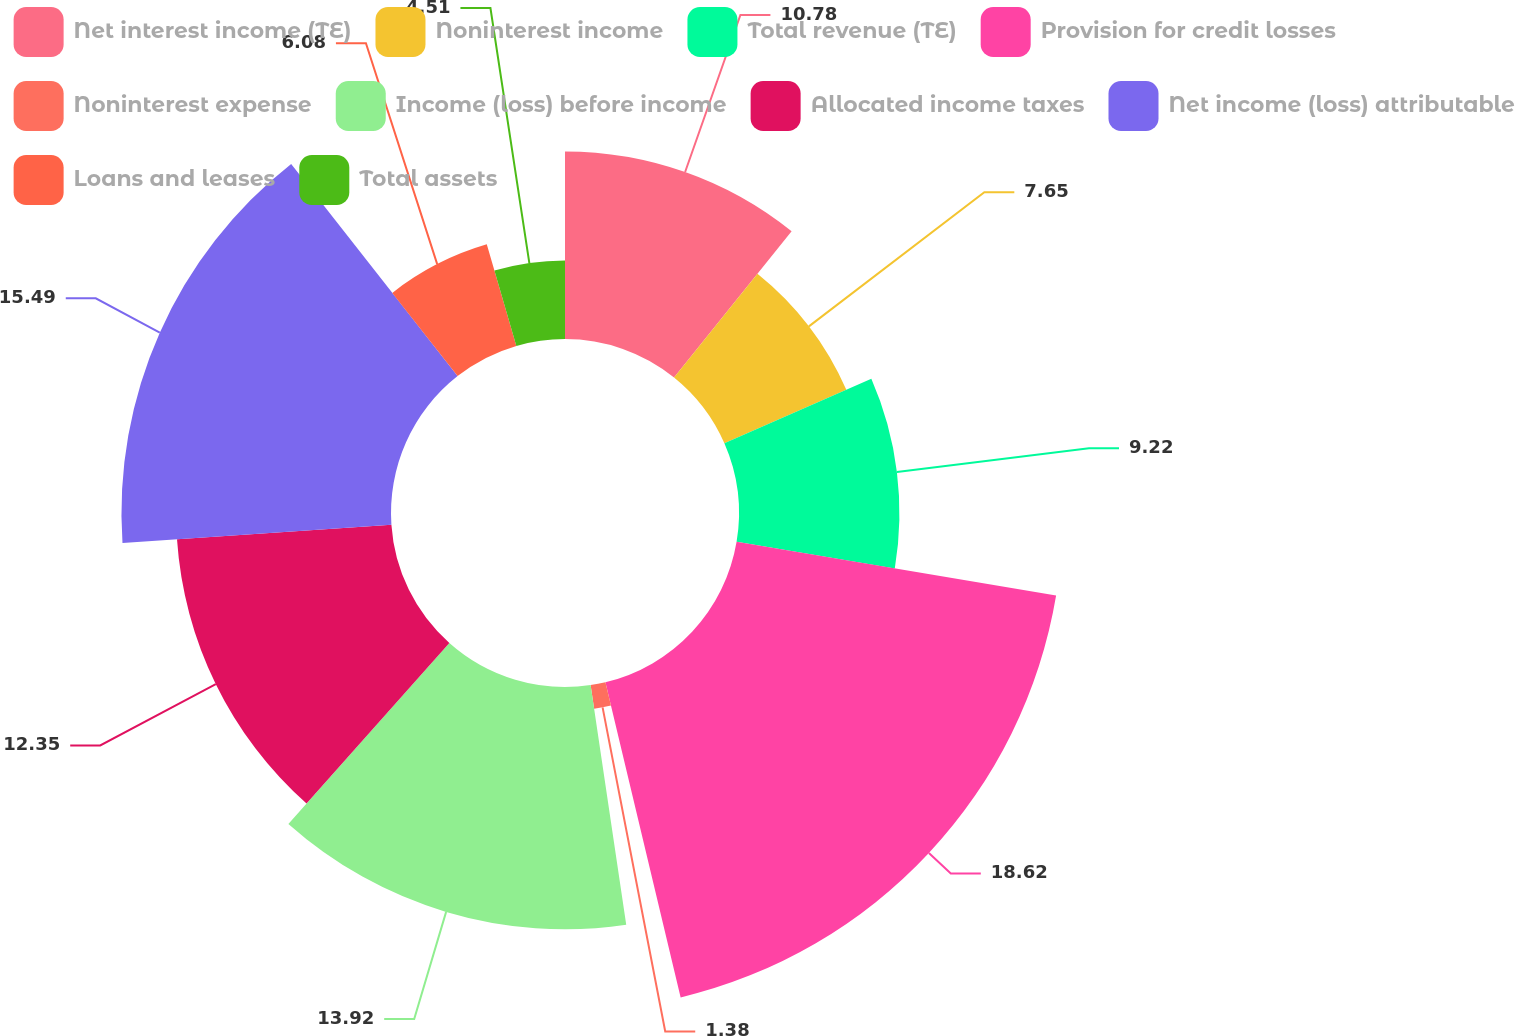<chart> <loc_0><loc_0><loc_500><loc_500><pie_chart><fcel>Net interest income (TE)<fcel>Noninterest income<fcel>Total revenue (TE)<fcel>Provision for credit losses<fcel>Noninterest expense<fcel>Income (loss) before income<fcel>Allocated income taxes<fcel>Net income (loss) attributable<fcel>Loans and leases<fcel>Total assets<nl><fcel>10.78%<fcel>7.65%<fcel>9.22%<fcel>18.62%<fcel>1.38%<fcel>13.92%<fcel>12.35%<fcel>15.49%<fcel>6.08%<fcel>4.51%<nl></chart> 